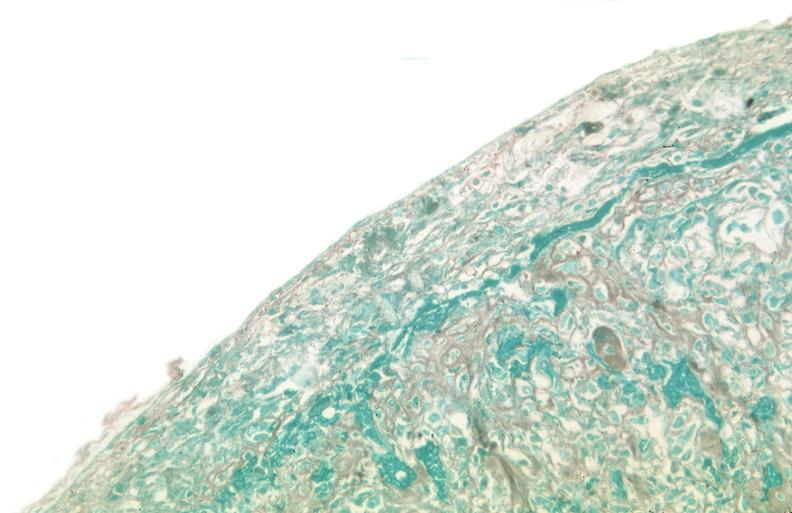was coronary artery anomalous origin left from pulmonary artery used to sclerose emphysematous lung, alpha-1 antitrypsin deficiency?
Answer the question using a single word or phrase. No 